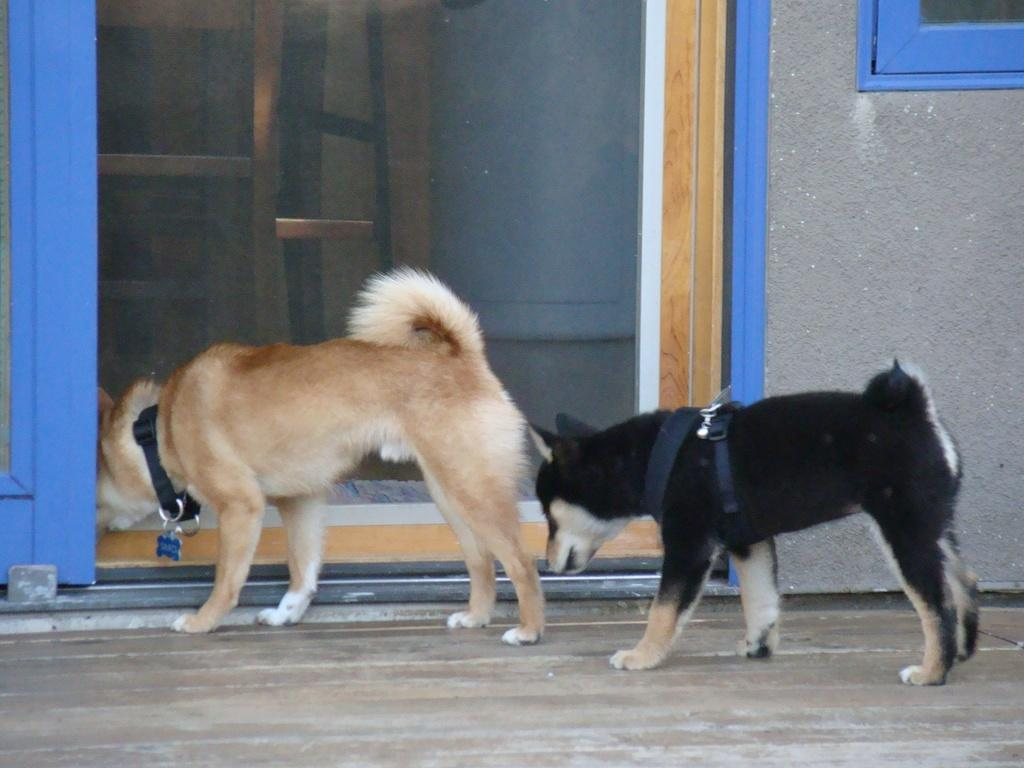What animals are present in the image? There are dogs standing on the ground in the image. What color is the door in the image? The door in the image is blue. What can be seen on the right side of the image? There is a wall with a window on the right side of the image. What language are the dogs using to have a discussion in the image? Dogs do not use language to communicate, so there is no discussion happening in the image. 